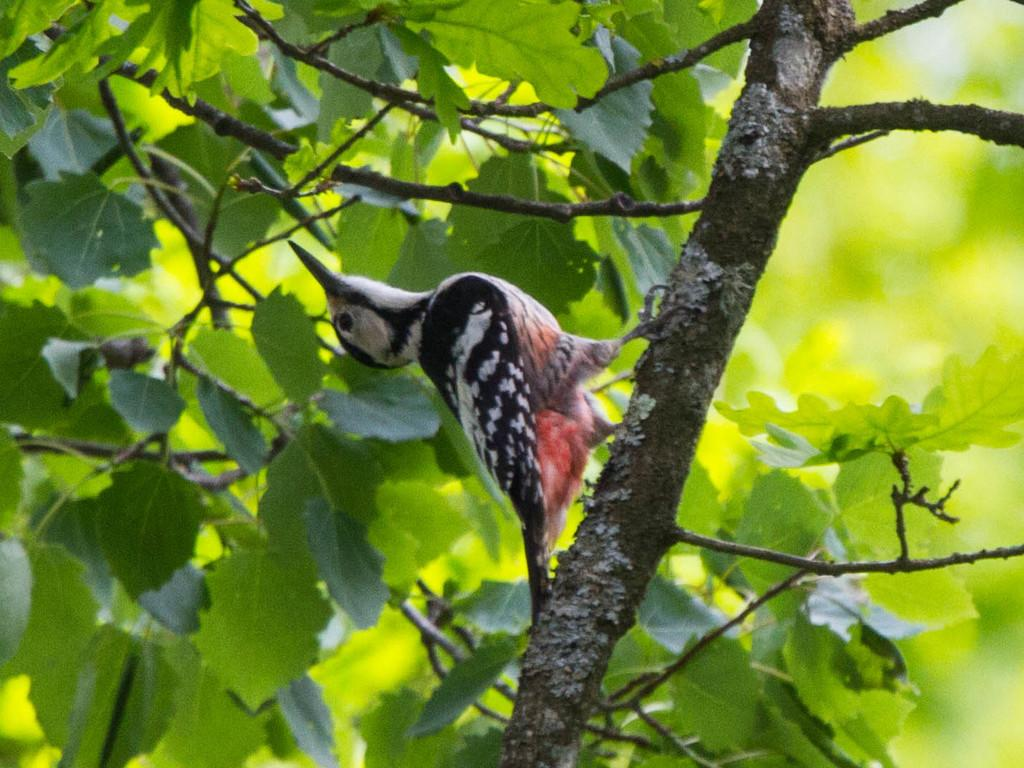What type of animal is in the image? There is a small bird in the image. What colors can be seen on the bird? The bird has black and red coloring. Where is the bird located in the image? The bird is sitting on a tree branch. What type of vegetation is visible in the image? There are green leaves visible in the image. What type of bed is visible in the image? There is no bed present in the image; it features a small bird sitting on a tree branch. What type of quilt is being used by the bird in the image? There is no quilt present in the image, as it features a bird sitting on a tree branch. 